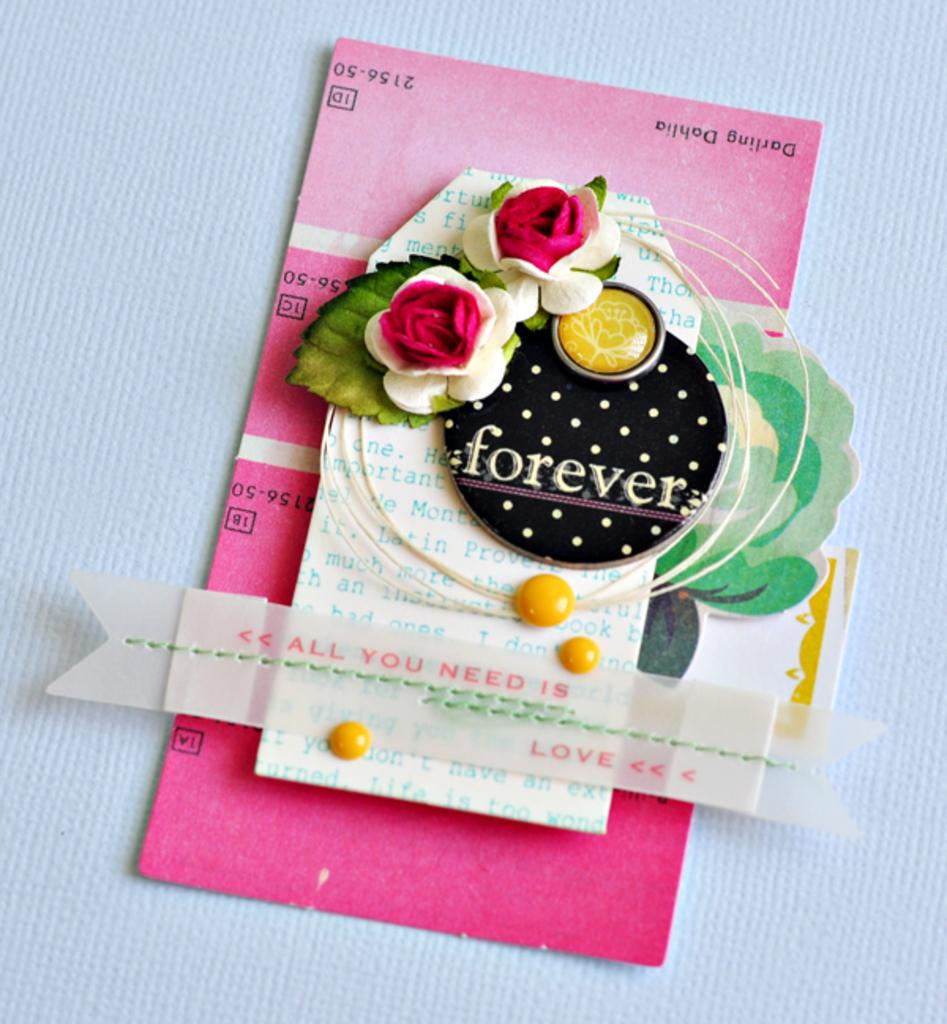What object is the main focus of the picture? There is a greeting card in the picture. What can be found on the greeting card? There is text on the greeting card. What color is the background of the greeting card? The background of the greeting card is white. What route does the airplane take in the image? There is no airplane present in the image, so it is not possible to determine the route it might take. 